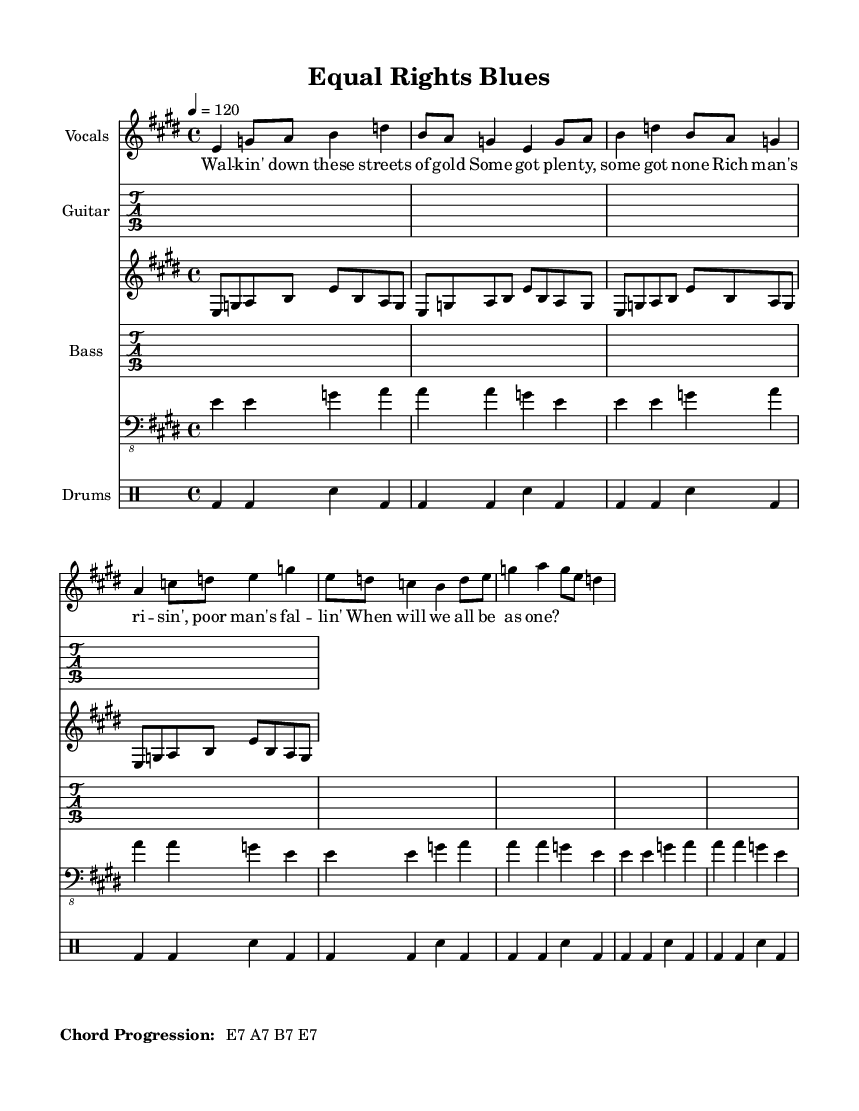What is the key signature of this music? The key signature is E major, which has four sharps: F#, C#, G#, and D#.
Answer: E major What is the time signature of this music? The time signature is found at the beginning and is indicated by the 4 over 4 notation. This indicates there are four beats per measure.
Answer: 4/4 What is the tempo marking of this piece? The tempo marking is indicated as 4 = 120, meaning the quarter note gets 120 beats per minute.
Answer: 120 How many lines are in the melody? The melody has four lines visible in the provided notation. Each line corresponds to distinct phrases in the music.
Answer: Four lines What are the chords used in the progression? The chord progression at the bottom lists E7, A7, B7, and ends with E7. These are typical chords in Electric Blues.
Answer: E7, A7, B7, E7 What is the overall theme of the lyrics? The lyrics focus on social inequality, highlighting the contrast between wealth and poverty. This theme is important in protest music.
Answer: Social inequality How is the guitar rhythm structured in this piece? The guitar riff repeats four times, which creates a strong rhythmic foundation typical in Electric Blues. This repetition is characteristic of the genre.
Answer: Repeats four times 